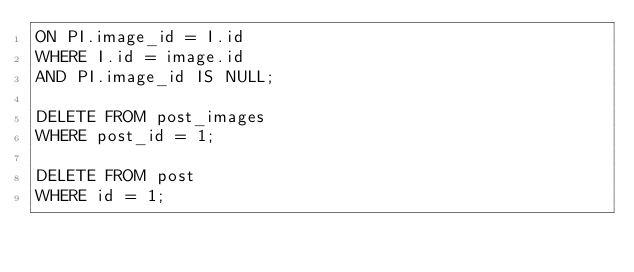<code> <loc_0><loc_0><loc_500><loc_500><_SQL_>ON PI.image_id = I.id
WHERE I.id = image.id
AND PI.image_id IS NULL;

DELETE FROM post_images
WHERE post_id = 1;

DELETE FROM post
WHERE id = 1;
</code> 